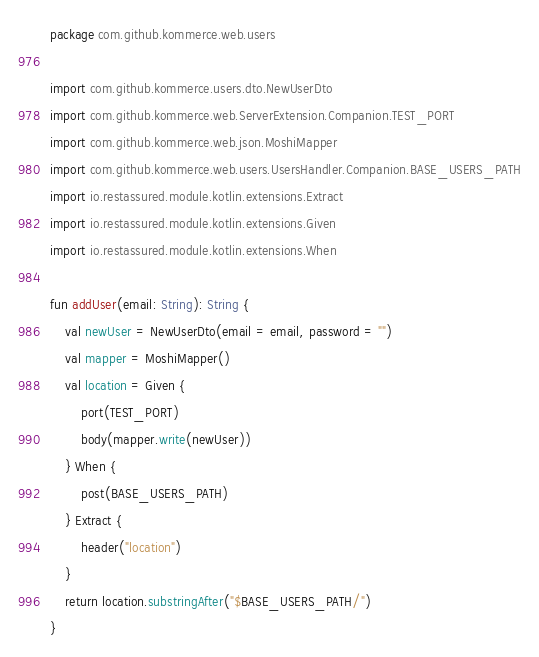<code> <loc_0><loc_0><loc_500><loc_500><_Kotlin_>package com.github.kommerce.web.users

import com.github.kommerce.users.dto.NewUserDto
import com.github.kommerce.web.ServerExtension.Companion.TEST_PORT
import com.github.kommerce.web.json.MoshiMapper
import com.github.kommerce.web.users.UsersHandler.Companion.BASE_USERS_PATH
import io.restassured.module.kotlin.extensions.Extract
import io.restassured.module.kotlin.extensions.Given
import io.restassured.module.kotlin.extensions.When

fun addUser(email: String): String {
    val newUser = NewUserDto(email = email, password = "")
    val mapper = MoshiMapper()
    val location = Given {
        port(TEST_PORT)
        body(mapper.write(newUser))
    } When {
        post(BASE_USERS_PATH)
    } Extract {
        header("location")
    }
    return location.substringAfter("$BASE_USERS_PATH/")
}</code> 